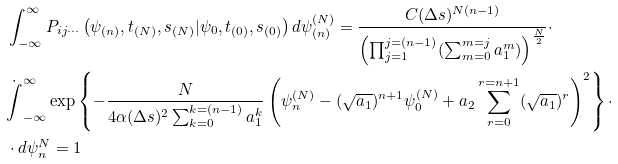Convert formula to latex. <formula><loc_0><loc_0><loc_500><loc_500>& \int _ { - \infty } ^ { \infty } P _ { i j \cdots } \left ( \psi _ { ( n ) } , t _ { ( N ) } , s _ { ( N ) } | \psi _ { 0 } , t _ { ( 0 ) } , s _ { ( 0 ) } \right ) d \psi ^ { ( N ) } _ { ( n ) } = \frac { C ( \Delta s ) ^ { N ( n - 1 ) } } { \left ( \prod _ { j = 1 } ^ { j = ( n - 1 ) } ( \sum _ { m = 0 } ^ { m = j } a _ { 1 } ^ { m } ) \right ) ^ { \frac { N } { 2 } } } \cdot \\ & \dot { \int } _ { - \infty } ^ { \infty } \exp \left \{ - \frac { N } { 4 \alpha ( \Delta s ) ^ { 2 } \sum _ { k = 0 } ^ { k = ( n - 1 ) } a _ { 1 } ^ { k } } \left ( \psi _ { n } ^ { ( N ) } - ( \sqrt { a _ { 1 } } ) ^ { n + 1 } \psi _ { 0 } ^ { ( N ) } + a _ { 2 } \sum _ { r = 0 } ^ { r = n + 1 } ( \sqrt { a _ { 1 } } ) ^ { r } \right ) ^ { 2 } \right \} \cdot \\ & \cdot d \psi ^ { N } _ { n } = 1</formula> 